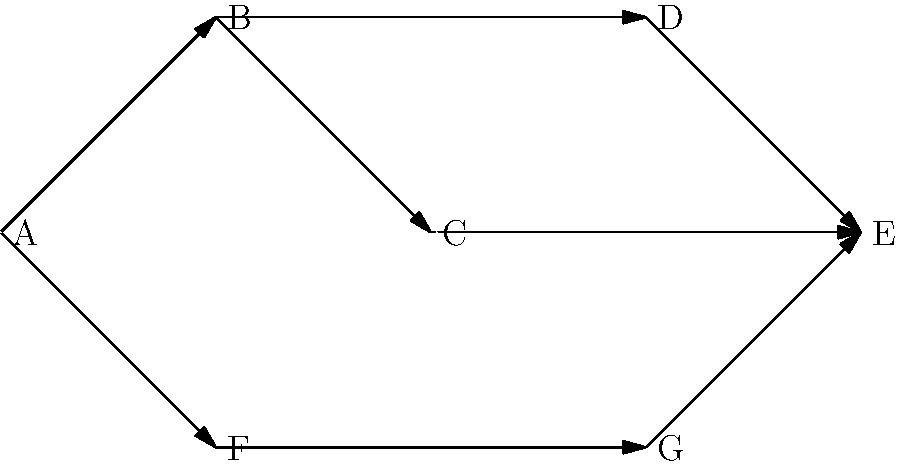In the given network diagram representing project dependencies and team connections, which node(s) represent critical junctions where multiple paths converge, potentially indicating key collaboration points or potential bottlenecks in the project workflow? To identify the critical junctions in this network diagram, we need to analyze the flow and connectivity of the nodes:

1. Start by observing the overall structure of the network.
2. Identify nodes with multiple incoming edges:
   - Node B has 1 incoming edge
   - Node C has 1 incoming edge
   - Node D has 1 incoming edge
   - Node E has 3 incoming edges
   - Node F has 1 incoming edge
   - Node G has 1 incoming edge
3. Nodes with multiple incoming edges represent points where different paths or tasks converge.
4. In this diagram, node E stands out as it has three incoming edges from nodes C, D, and G.
5. This indicates that node E is a critical junction where multiple paths converge.
6. From a project management perspective, node E likely represents:
   - A key collaboration point where multiple team efforts come together
   - A potential bottleneck if not managed properly, as it depends on the completion of multiple preceding tasks
   - A crucial milestone or deliverable in the project workflow

Therefore, node E is the primary critical junction in this network diagram.
Answer: E 